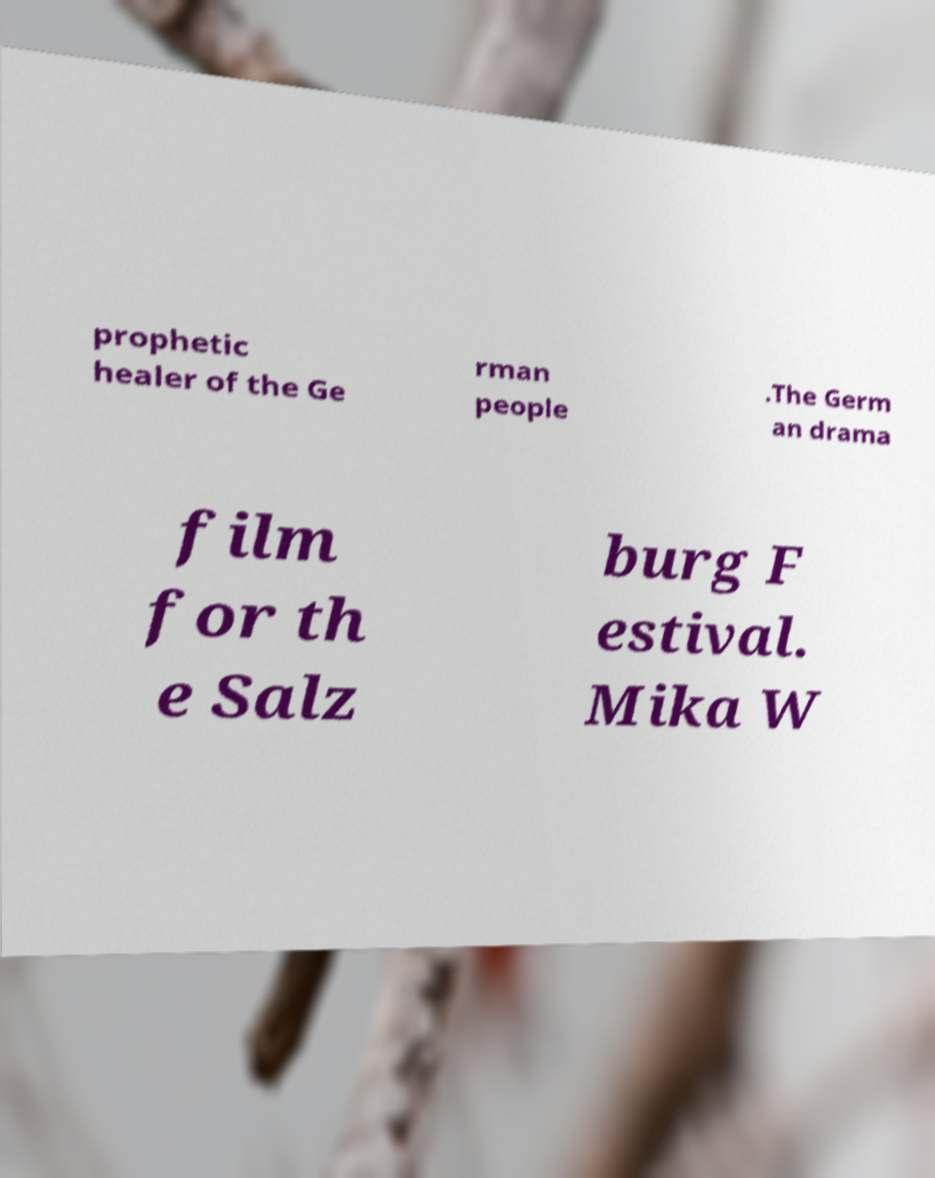What messages or text are displayed in this image? I need them in a readable, typed format. prophetic healer of the Ge rman people .The Germ an drama film for th e Salz burg F estival. Mika W 